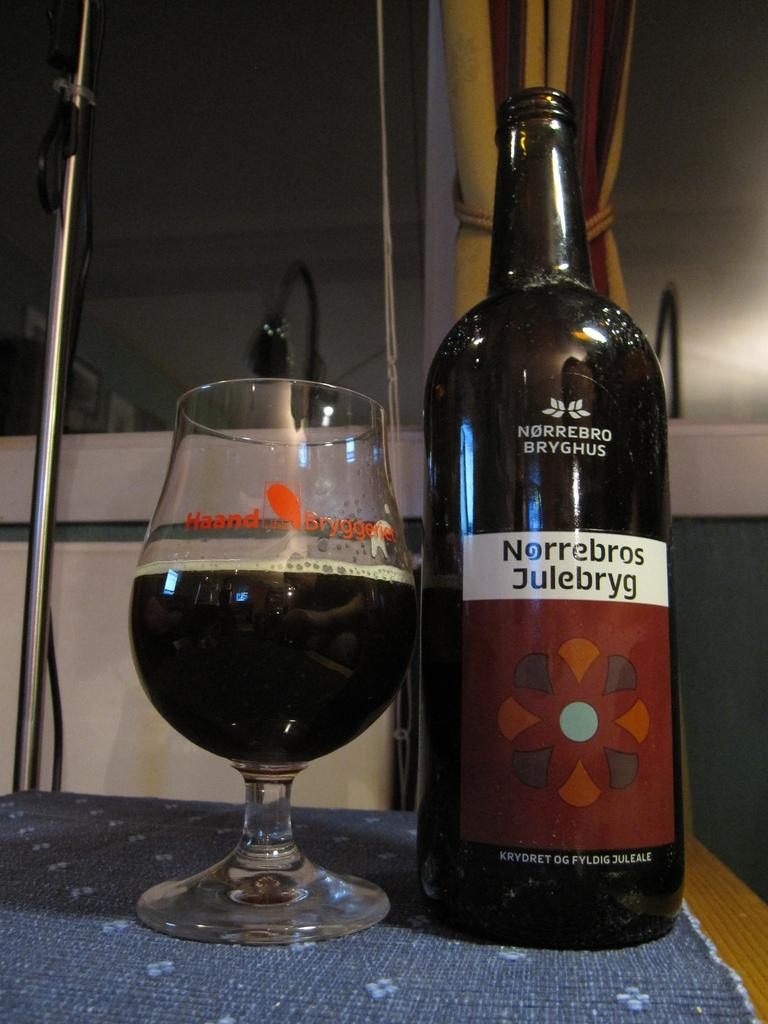<image>
Offer a succinct explanation of the picture presented. A bottle of Norrebros Julebryg is on a table next to a glass. 